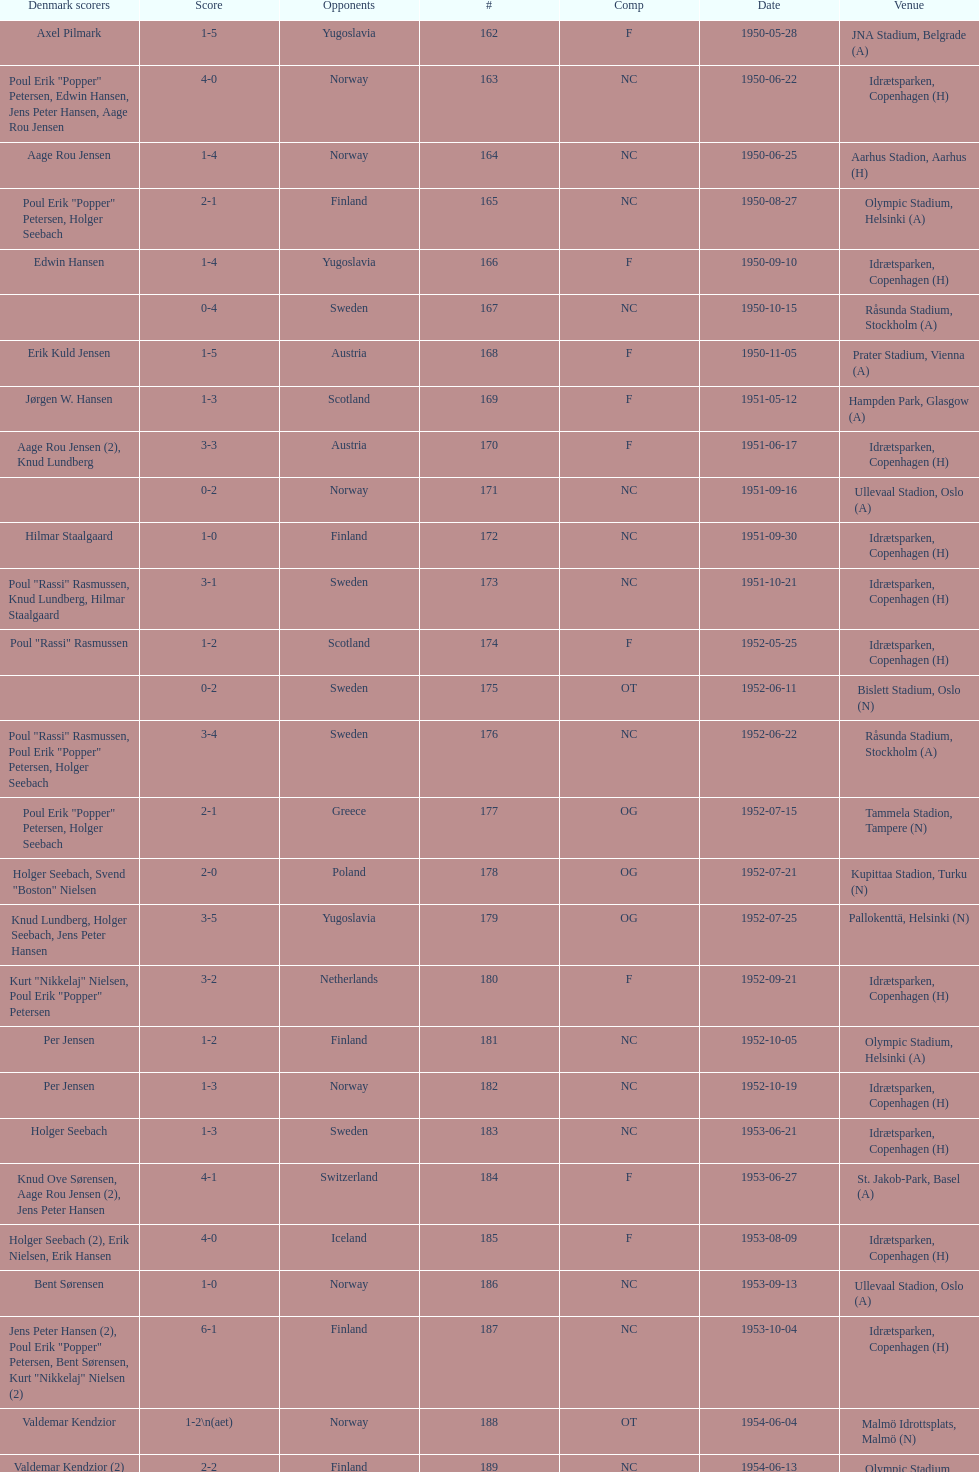Which game had a higher total score, #163 or #181? 163. 